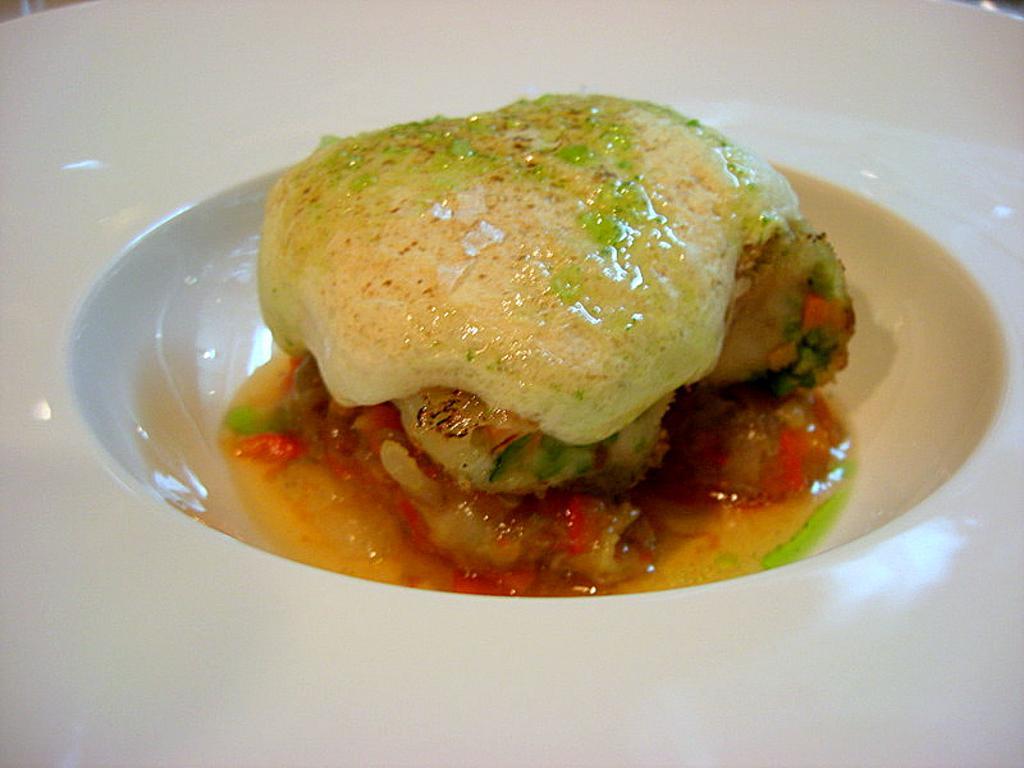How would you summarize this image in a sentence or two? In this image I can see a white colour bowl like thing and in it I can see food. 